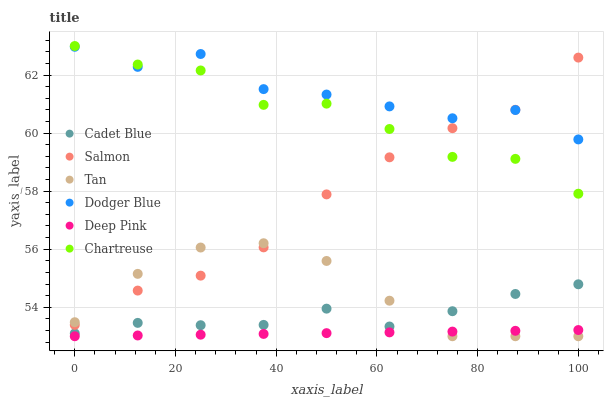Does Deep Pink have the minimum area under the curve?
Answer yes or no. Yes. Does Dodger Blue have the maximum area under the curve?
Answer yes or no. Yes. Does Salmon have the minimum area under the curve?
Answer yes or no. No. Does Salmon have the maximum area under the curve?
Answer yes or no. No. Is Deep Pink the smoothest?
Answer yes or no. Yes. Is Dodger Blue the roughest?
Answer yes or no. Yes. Is Salmon the smoothest?
Answer yes or no. No. Is Salmon the roughest?
Answer yes or no. No. Does Deep Pink have the lowest value?
Answer yes or no. Yes. Does Salmon have the lowest value?
Answer yes or no. No. Does Chartreuse have the highest value?
Answer yes or no. Yes. Does Salmon have the highest value?
Answer yes or no. No. Is Cadet Blue less than Salmon?
Answer yes or no. Yes. Is Dodger Blue greater than Tan?
Answer yes or no. Yes. Does Salmon intersect Tan?
Answer yes or no. Yes. Is Salmon less than Tan?
Answer yes or no. No. Is Salmon greater than Tan?
Answer yes or no. No. Does Cadet Blue intersect Salmon?
Answer yes or no. No. 